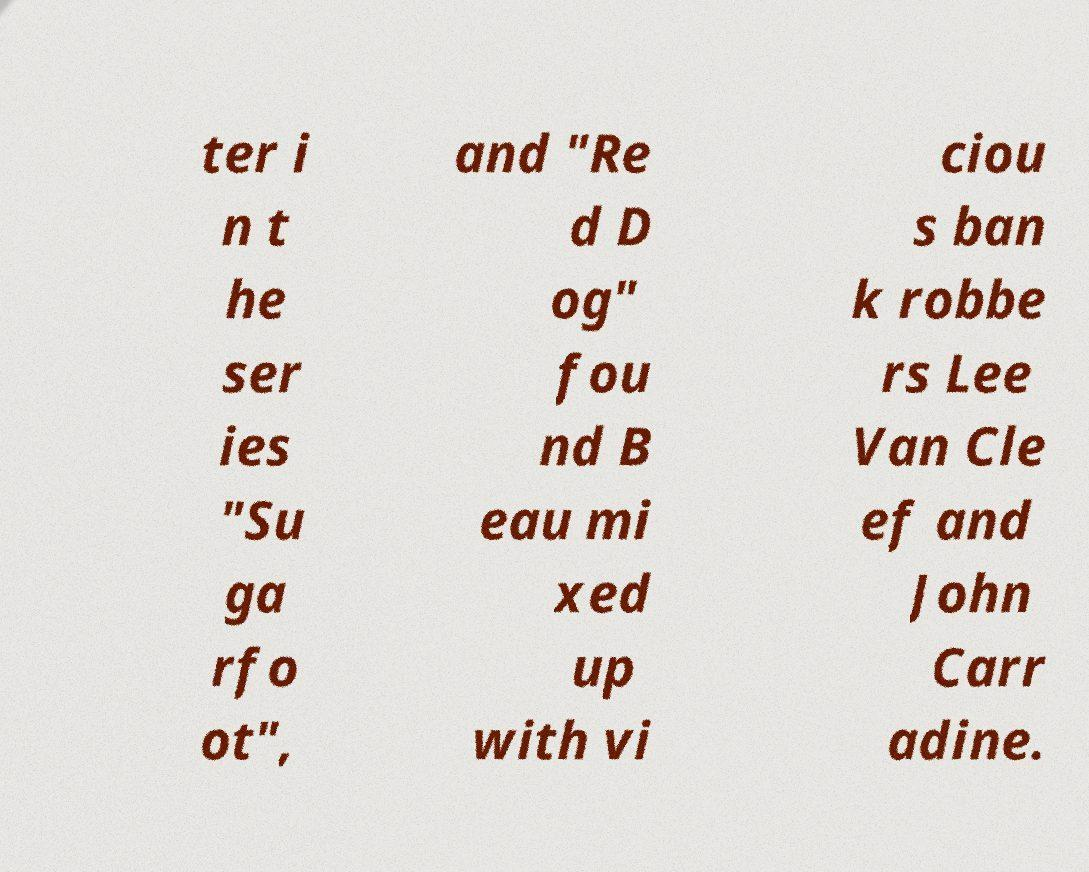For documentation purposes, I need the text within this image transcribed. Could you provide that? ter i n t he ser ies "Su ga rfo ot", and "Re d D og" fou nd B eau mi xed up with vi ciou s ban k robbe rs Lee Van Cle ef and John Carr adine. 